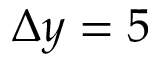Convert formula to latex. <formula><loc_0><loc_0><loc_500><loc_500>\Delta y = 5</formula> 